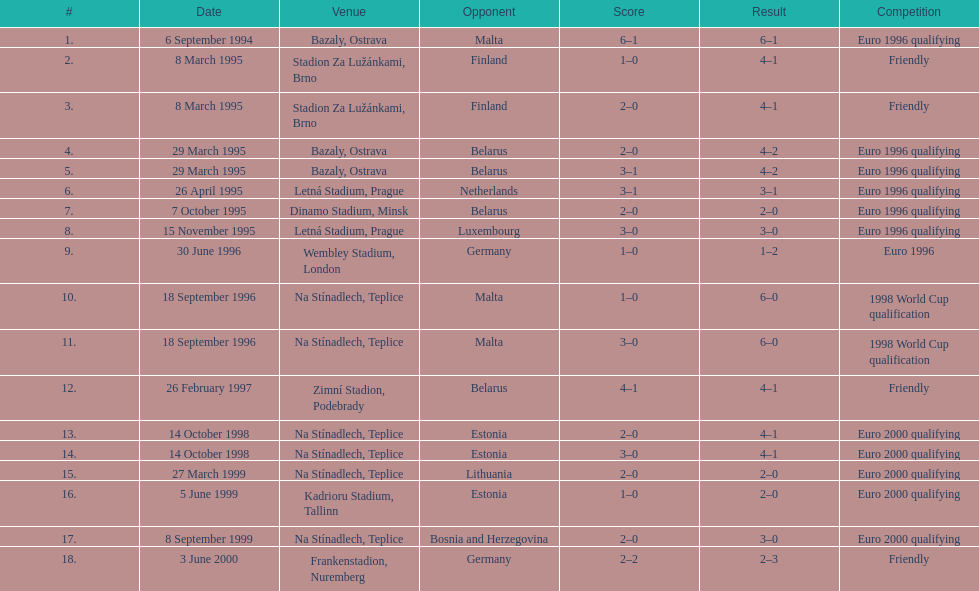What opponent is listed last on the table? Germany. 